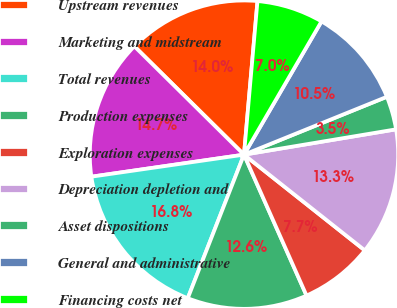Convert chart to OTSL. <chart><loc_0><loc_0><loc_500><loc_500><pie_chart><fcel>Upstream revenues<fcel>Marketing and midstream<fcel>Total revenues<fcel>Production expenses<fcel>Exploration expenses<fcel>Depreciation depletion and<fcel>Asset dispositions<fcel>General and administrative<fcel>Financing costs net<nl><fcel>13.99%<fcel>14.69%<fcel>16.78%<fcel>12.59%<fcel>7.69%<fcel>13.29%<fcel>3.5%<fcel>10.49%<fcel>6.99%<nl></chart> 